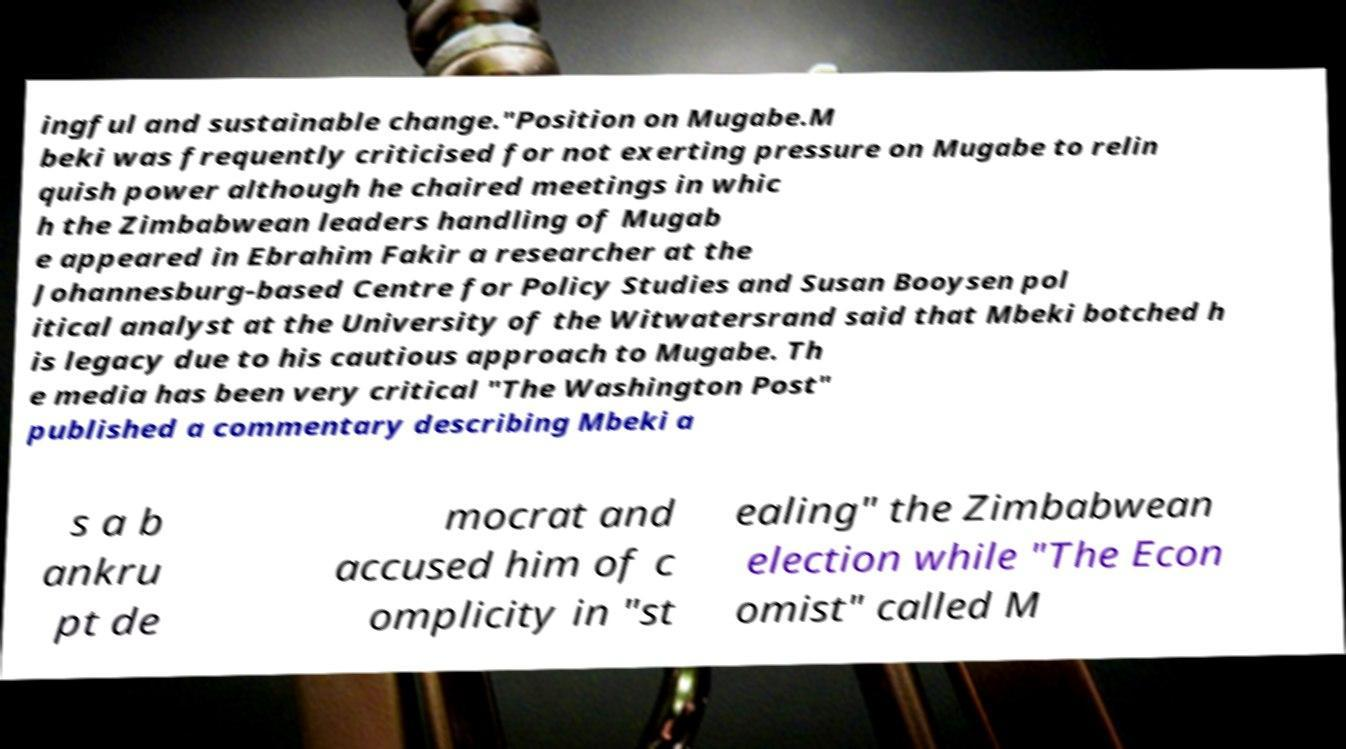Can you accurately transcribe the text from the provided image for me? ingful and sustainable change."Position on Mugabe.M beki was frequently criticised for not exerting pressure on Mugabe to relin quish power although he chaired meetings in whic h the Zimbabwean leaders handling of Mugab e appeared in Ebrahim Fakir a researcher at the Johannesburg-based Centre for Policy Studies and Susan Booysen pol itical analyst at the University of the Witwatersrand said that Mbeki botched h is legacy due to his cautious approach to Mugabe. Th e media has been very critical "The Washington Post" published a commentary describing Mbeki a s a b ankru pt de mocrat and accused him of c omplicity in "st ealing" the Zimbabwean election while "The Econ omist" called M 